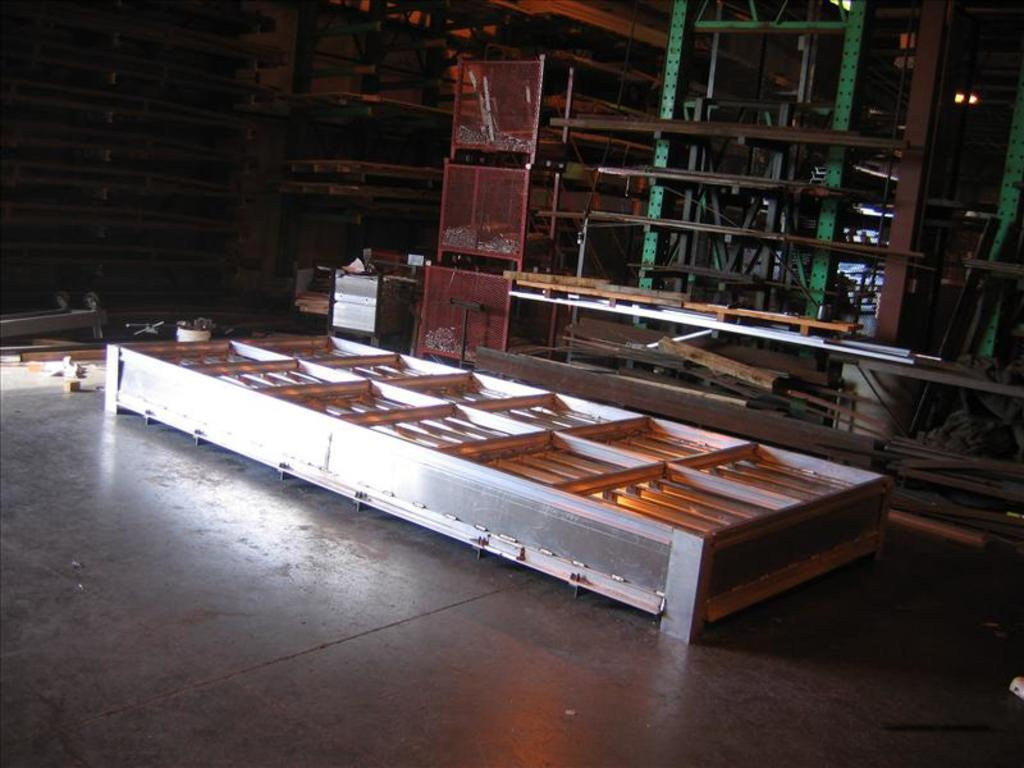What type of surface is visible in the image? There is ground visible in the image. What materials are the objects on the ground made of? The objects on the ground are made of metallic and wooden materials. What type of toy can be seen on the ground in the image? There is no toy present in the image; only metallic and wooden objects are visible on the ground. What color are the oranges on the ground in the image? There are no oranges present in the image; only metallic and wooden objects are visible on the ground. 